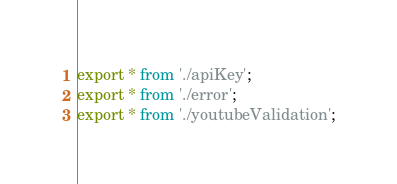Convert code to text. <code><loc_0><loc_0><loc_500><loc_500><_TypeScript_>export * from './apiKey';
export * from './error';
export * from './youtubeValidation';
</code> 